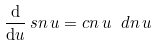Convert formula to latex. <formula><loc_0><loc_0><loc_500><loc_500>\frac { \mathrm d } { \mathrm d u } \, s n \, u = c n \, u \ d n \, u</formula> 